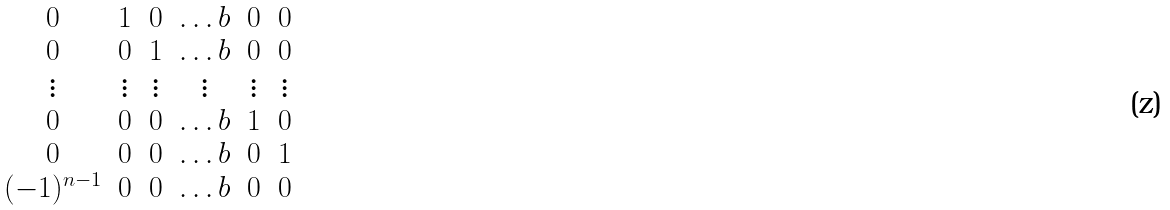<formula> <loc_0><loc_0><loc_500><loc_500>\begin{matrix} 0 & 1 & 0 & \dots b & 0 & 0 \\ 0 & 0 & 1 & \dots b & 0 & 0 \\ \vdots & \vdots & \vdots & \vdots & \vdots & \vdots \\ 0 & 0 & 0 & \dots b & 1 & 0 \\ 0 & 0 & 0 & \dots b & 0 & 1 \\ ( - 1 ) ^ { n - 1 } & 0 & 0 & \dots b & 0 & 0 \end{matrix}</formula> 